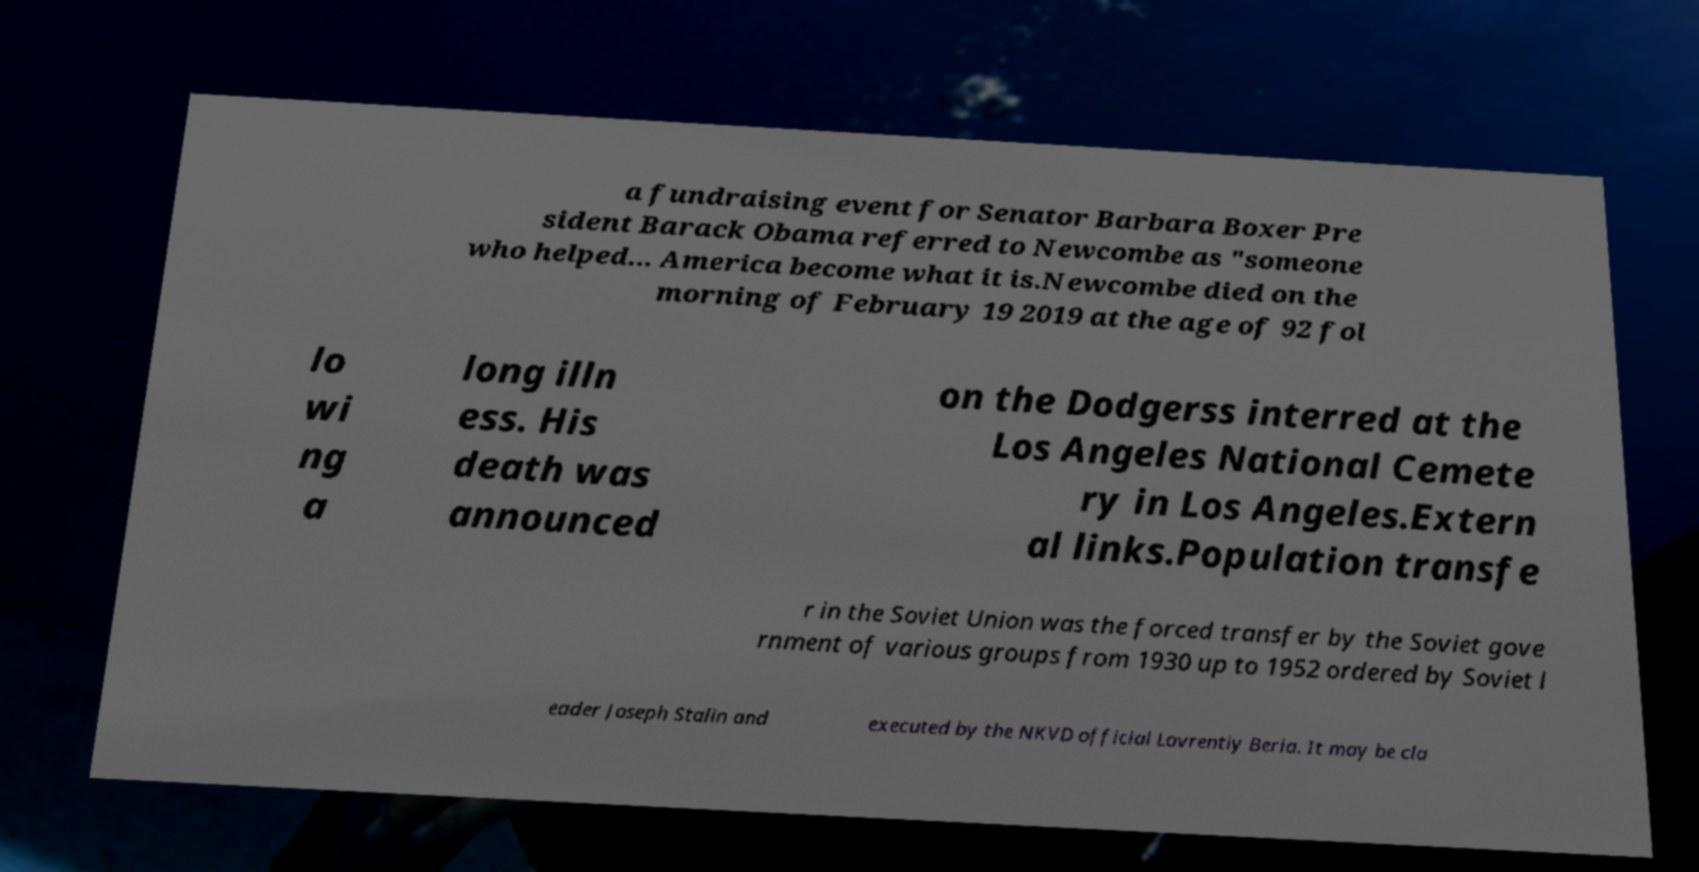Please identify and transcribe the text found in this image. a fundraising event for Senator Barbara Boxer Pre sident Barack Obama referred to Newcombe as "someone who helped... America become what it is.Newcombe died on the morning of February 19 2019 at the age of 92 fol lo wi ng a long illn ess. His death was announced on the Dodgerss interred at the Los Angeles National Cemete ry in Los Angeles.Extern al links.Population transfe r in the Soviet Union was the forced transfer by the Soviet gove rnment of various groups from 1930 up to 1952 ordered by Soviet l eader Joseph Stalin and executed by the NKVD official Lavrentiy Beria. It may be cla 